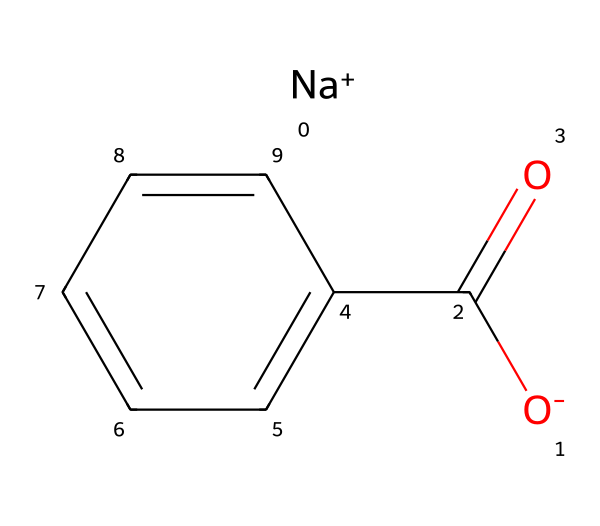How many carbon atoms are in sodium benzoate? The chemical structure shows one part connected to a carbonyl group (C(=O)) and a phenyl ring (c1ccccc1). Initially counting from the carbonyl and the phenyl ring, we find that there are seven carbon atoms in total: one from the carbonyl and six from the benzene ring.
Answer: seven What type of bond connects sodium to the rest of the molecule? In the chemical structure, the sodium ion ([Na+]) indicates an ionic bond, where the positively charged sodium ion is bonded to the negatively charged carboxylate ion (the rest of the molecule). Ionic bonds form between a metal and a non-metal.
Answer: ionic Is sodium benzoate a solid at room temperature? Sodium benzoate is commonly found in solid form as a white crystalline powder at room temperature. Its structure supports stability in solid form due to ionic interactions between sodium and the carboxylate group.
Answer: yes What functional group does sodium benzoate contain? In the structure, the carboxylate group (C(=O)O-) indicates the presence of a functional group. The presence of a carbon atom double-bonded to an oxygen atom and single-bonded to an oxygen atom directly confirms this.
Answer: carboxylate How does sodium benzoate act as a preservative? The structure features a carboxylate functional group which can inhibit microbial growth by lowering pH in acidic foods, and by disrupting cellular metabolism and permeability. This functionality allows sodium benzoate to limit spoilage in various products.
Answer: by lowering pH 